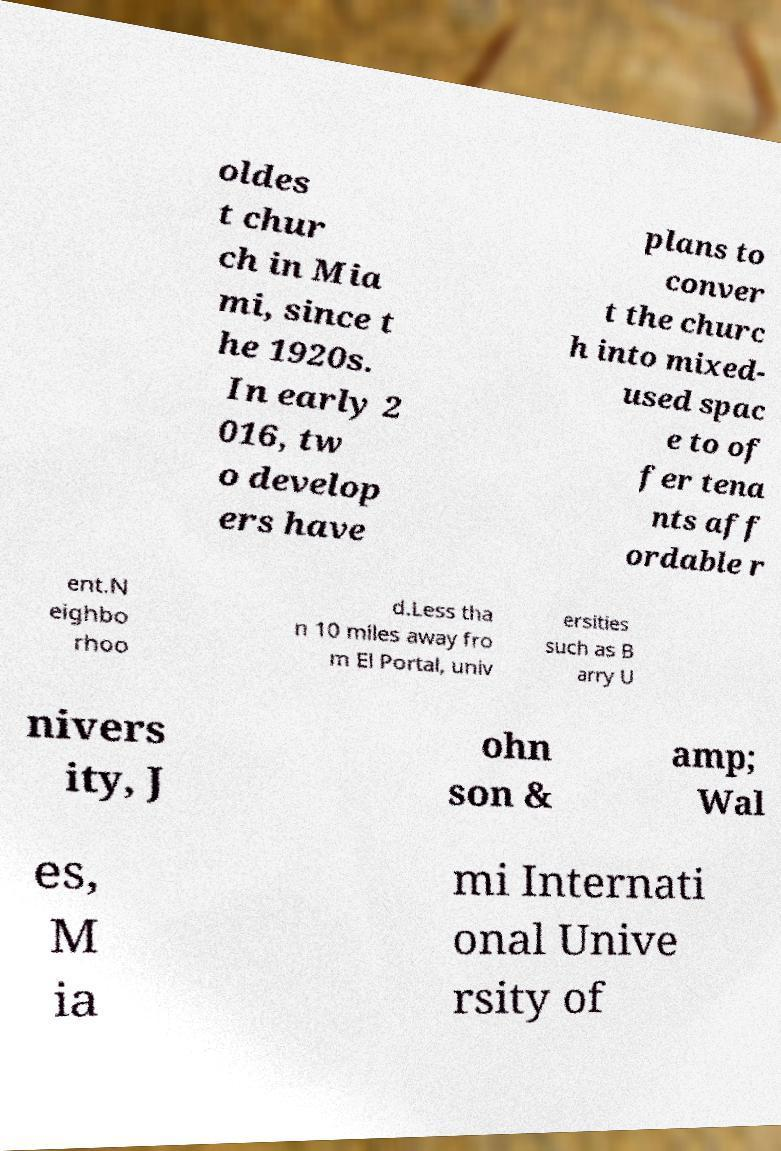What messages or text are displayed in this image? I need them in a readable, typed format. oldes t chur ch in Mia mi, since t he 1920s. In early 2 016, tw o develop ers have plans to conver t the churc h into mixed- used spac e to of fer tena nts aff ordable r ent.N eighbo rhoo d.Less tha n 10 miles away fro m El Portal, univ ersities such as B arry U nivers ity, J ohn son & amp; Wal es, M ia mi Internati onal Unive rsity of 